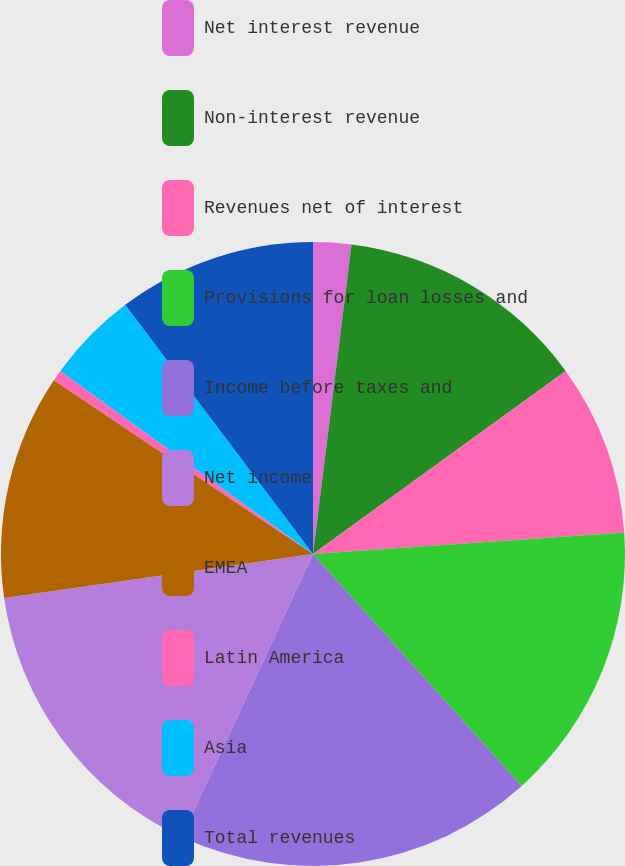Convert chart. <chart><loc_0><loc_0><loc_500><loc_500><pie_chart><fcel>Net interest revenue<fcel>Non-interest revenue<fcel>Revenues net of interest<fcel>Provisions for loan losses and<fcel>Income before taxes and<fcel>Net income<fcel>EMEA<fcel>Latin America<fcel>Asia<fcel>Total revenues<nl><fcel>1.97%<fcel>13.05%<fcel>8.89%<fcel>14.43%<fcel>18.59%<fcel>15.82%<fcel>11.66%<fcel>0.58%<fcel>4.74%<fcel>10.28%<nl></chart> 